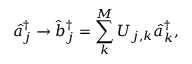<formula> <loc_0><loc_0><loc_500><loc_500>\hat { a } _ { j } ^ { \dag } \rightarrow \hat { b } _ { j } ^ { \dag } = \sum _ { k } ^ { M } U _ { j , k } \hat { a } _ { k } ^ { \dag } ,</formula> 